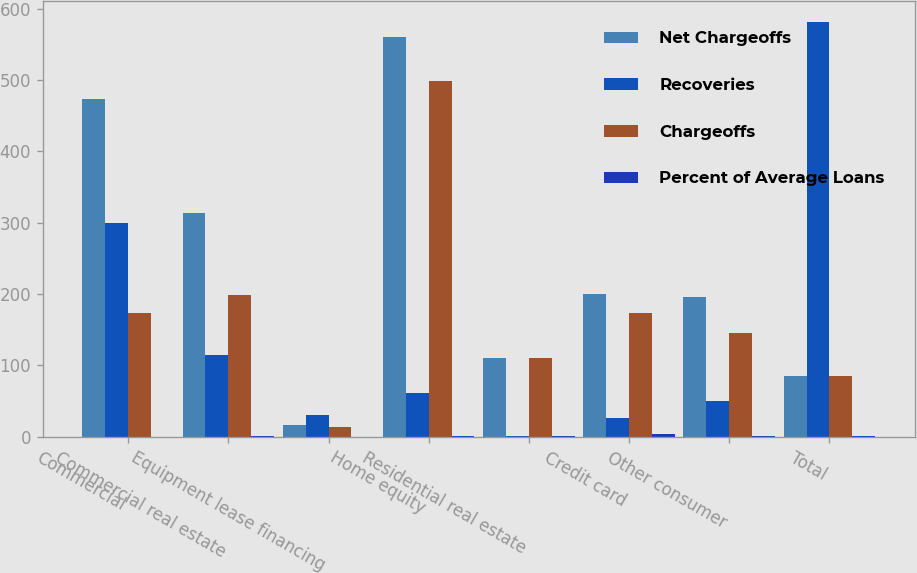Convert chart. <chart><loc_0><loc_0><loc_500><loc_500><stacked_bar_chart><ecel><fcel>Commercial<fcel>Commercial real estate<fcel>Equipment lease financing<fcel>Home equity<fcel>Residential real estate<fcel>Credit card<fcel>Other consumer<fcel>Total<nl><fcel>Net Chargeoffs<fcel>474<fcel>314<fcel>16<fcel>560<fcel>110<fcel>200<fcel>196<fcel>85.5<nl><fcel>Recoveries<fcel>300<fcel>115<fcel>30<fcel>61<fcel>1<fcel>26<fcel>50<fcel>581<nl><fcel>Chargeoffs<fcel>174<fcel>199<fcel>14<fcel>499<fcel>111<fcel>174<fcel>146<fcel>85.5<nl><fcel>Percent of Average Loans<fcel>0.23<fcel>1.1<fcel>0.21<fcel>1.41<fcel>0.72<fcel>4.26<fcel>0.72<fcel>0.73<nl></chart> 